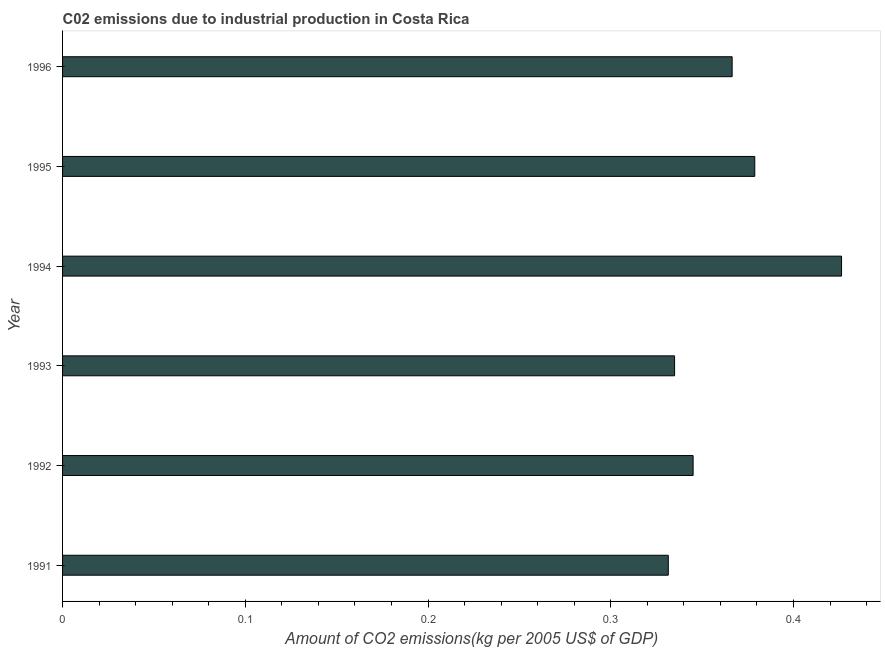Does the graph contain any zero values?
Ensure brevity in your answer.  No. What is the title of the graph?
Your answer should be compact. C02 emissions due to industrial production in Costa Rica. What is the label or title of the X-axis?
Keep it short and to the point. Amount of CO2 emissions(kg per 2005 US$ of GDP). What is the amount of co2 emissions in 1993?
Your answer should be very brief. 0.33. Across all years, what is the maximum amount of co2 emissions?
Give a very brief answer. 0.43. Across all years, what is the minimum amount of co2 emissions?
Ensure brevity in your answer.  0.33. What is the sum of the amount of co2 emissions?
Your response must be concise. 2.18. What is the difference between the amount of co2 emissions in 1994 and 1996?
Ensure brevity in your answer.  0.06. What is the average amount of co2 emissions per year?
Your answer should be compact. 0.36. What is the median amount of co2 emissions?
Keep it short and to the point. 0.36. In how many years, is the amount of co2 emissions greater than 0.18 kg per 2005 US$ of GDP?
Your response must be concise. 6. What is the ratio of the amount of co2 emissions in 1995 to that in 1996?
Provide a succinct answer. 1.03. Is the amount of co2 emissions in 1991 less than that in 1992?
Provide a short and direct response. Yes. What is the difference between the highest and the second highest amount of co2 emissions?
Your answer should be very brief. 0.05. What is the difference between the highest and the lowest amount of co2 emissions?
Offer a very short reply. 0.09. In how many years, is the amount of co2 emissions greater than the average amount of co2 emissions taken over all years?
Give a very brief answer. 3. Are all the bars in the graph horizontal?
Give a very brief answer. Yes. How many years are there in the graph?
Your answer should be compact. 6. What is the difference between two consecutive major ticks on the X-axis?
Keep it short and to the point. 0.1. Are the values on the major ticks of X-axis written in scientific E-notation?
Offer a terse response. No. What is the Amount of CO2 emissions(kg per 2005 US$ of GDP) in 1991?
Keep it short and to the point. 0.33. What is the Amount of CO2 emissions(kg per 2005 US$ of GDP) of 1992?
Ensure brevity in your answer.  0.35. What is the Amount of CO2 emissions(kg per 2005 US$ of GDP) in 1993?
Ensure brevity in your answer.  0.33. What is the Amount of CO2 emissions(kg per 2005 US$ of GDP) of 1994?
Make the answer very short. 0.43. What is the Amount of CO2 emissions(kg per 2005 US$ of GDP) in 1995?
Provide a short and direct response. 0.38. What is the Amount of CO2 emissions(kg per 2005 US$ of GDP) of 1996?
Keep it short and to the point. 0.37. What is the difference between the Amount of CO2 emissions(kg per 2005 US$ of GDP) in 1991 and 1992?
Ensure brevity in your answer.  -0.01. What is the difference between the Amount of CO2 emissions(kg per 2005 US$ of GDP) in 1991 and 1993?
Keep it short and to the point. -0. What is the difference between the Amount of CO2 emissions(kg per 2005 US$ of GDP) in 1991 and 1994?
Your response must be concise. -0.09. What is the difference between the Amount of CO2 emissions(kg per 2005 US$ of GDP) in 1991 and 1995?
Your answer should be compact. -0.05. What is the difference between the Amount of CO2 emissions(kg per 2005 US$ of GDP) in 1991 and 1996?
Keep it short and to the point. -0.03. What is the difference between the Amount of CO2 emissions(kg per 2005 US$ of GDP) in 1992 and 1993?
Your answer should be compact. 0.01. What is the difference between the Amount of CO2 emissions(kg per 2005 US$ of GDP) in 1992 and 1994?
Provide a succinct answer. -0.08. What is the difference between the Amount of CO2 emissions(kg per 2005 US$ of GDP) in 1992 and 1995?
Your answer should be very brief. -0.03. What is the difference between the Amount of CO2 emissions(kg per 2005 US$ of GDP) in 1992 and 1996?
Give a very brief answer. -0.02. What is the difference between the Amount of CO2 emissions(kg per 2005 US$ of GDP) in 1993 and 1994?
Offer a terse response. -0.09. What is the difference between the Amount of CO2 emissions(kg per 2005 US$ of GDP) in 1993 and 1995?
Keep it short and to the point. -0.04. What is the difference between the Amount of CO2 emissions(kg per 2005 US$ of GDP) in 1993 and 1996?
Provide a short and direct response. -0.03. What is the difference between the Amount of CO2 emissions(kg per 2005 US$ of GDP) in 1994 and 1995?
Give a very brief answer. 0.05. What is the difference between the Amount of CO2 emissions(kg per 2005 US$ of GDP) in 1994 and 1996?
Your answer should be compact. 0.06. What is the difference between the Amount of CO2 emissions(kg per 2005 US$ of GDP) in 1995 and 1996?
Your answer should be very brief. 0.01. What is the ratio of the Amount of CO2 emissions(kg per 2005 US$ of GDP) in 1991 to that in 1992?
Give a very brief answer. 0.96. What is the ratio of the Amount of CO2 emissions(kg per 2005 US$ of GDP) in 1991 to that in 1993?
Ensure brevity in your answer.  0.99. What is the ratio of the Amount of CO2 emissions(kg per 2005 US$ of GDP) in 1991 to that in 1994?
Your response must be concise. 0.78. What is the ratio of the Amount of CO2 emissions(kg per 2005 US$ of GDP) in 1991 to that in 1996?
Keep it short and to the point. 0.91. What is the ratio of the Amount of CO2 emissions(kg per 2005 US$ of GDP) in 1992 to that in 1994?
Offer a terse response. 0.81. What is the ratio of the Amount of CO2 emissions(kg per 2005 US$ of GDP) in 1992 to that in 1995?
Offer a very short reply. 0.91. What is the ratio of the Amount of CO2 emissions(kg per 2005 US$ of GDP) in 1992 to that in 1996?
Ensure brevity in your answer.  0.94. What is the ratio of the Amount of CO2 emissions(kg per 2005 US$ of GDP) in 1993 to that in 1994?
Give a very brief answer. 0.79. What is the ratio of the Amount of CO2 emissions(kg per 2005 US$ of GDP) in 1993 to that in 1995?
Offer a very short reply. 0.88. What is the ratio of the Amount of CO2 emissions(kg per 2005 US$ of GDP) in 1993 to that in 1996?
Offer a very short reply. 0.91. What is the ratio of the Amount of CO2 emissions(kg per 2005 US$ of GDP) in 1994 to that in 1996?
Your response must be concise. 1.16. What is the ratio of the Amount of CO2 emissions(kg per 2005 US$ of GDP) in 1995 to that in 1996?
Provide a short and direct response. 1.03. 